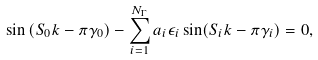<formula> <loc_0><loc_0><loc_500><loc_500>\sin \left ( S _ { 0 } k - \pi \gamma _ { 0 } \right ) - \sum _ { i = 1 } ^ { N _ { \Gamma } } a _ { i } \epsilon _ { i } \sin ( S _ { i } k - \pi \gamma _ { i } ) = 0 ,</formula> 